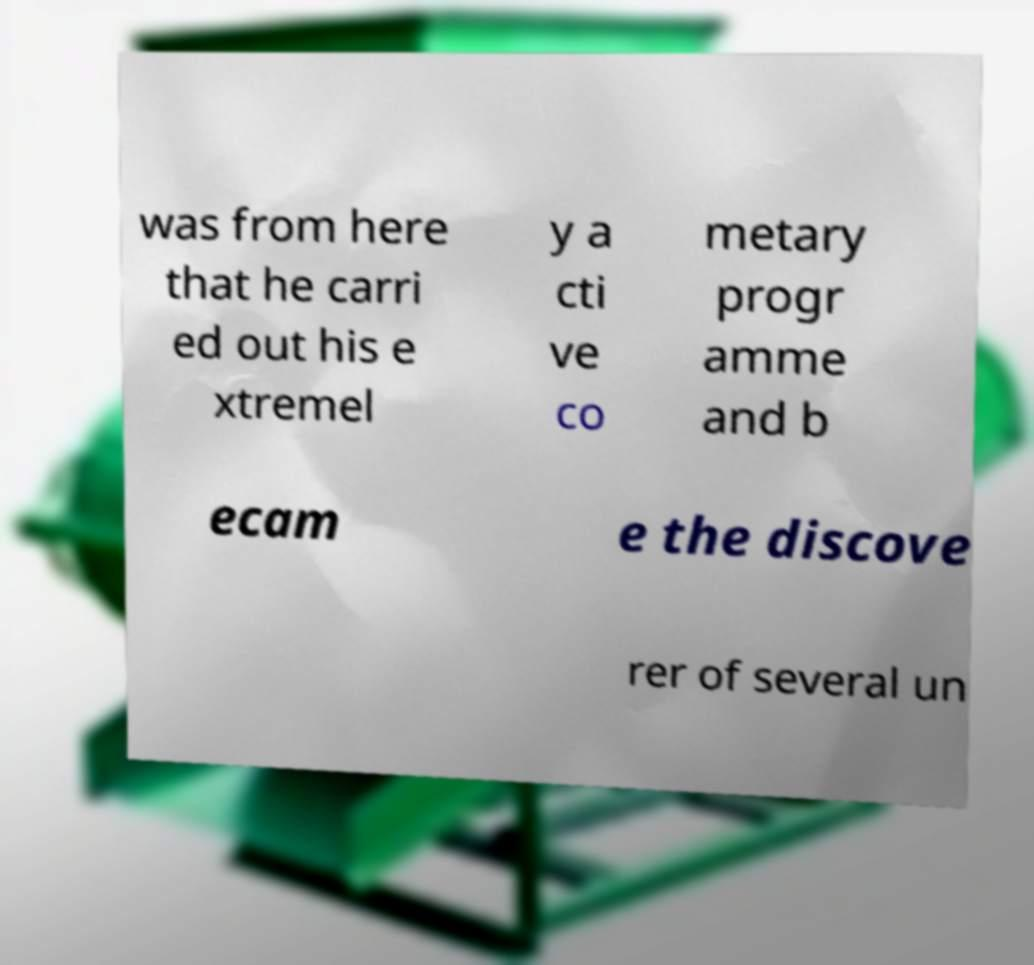Please read and relay the text visible in this image. What does it say? was from here that he carri ed out his e xtremel y a cti ve co metary progr amme and b ecam e the discove rer of several un 